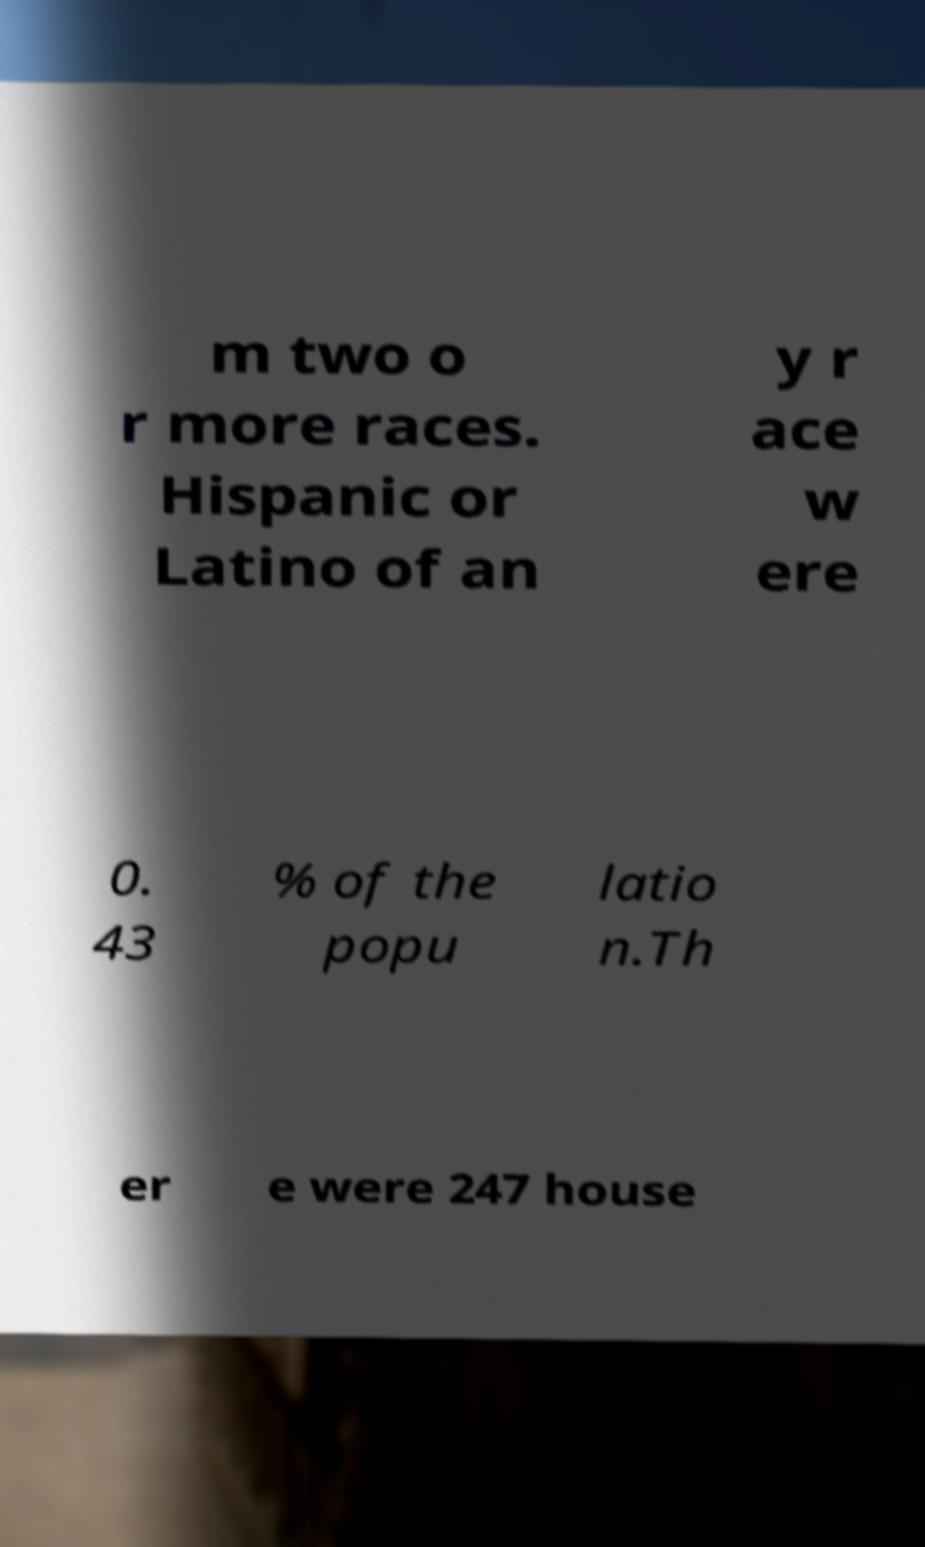Could you assist in decoding the text presented in this image and type it out clearly? m two o r more races. Hispanic or Latino of an y r ace w ere 0. 43 % of the popu latio n.Th er e were 247 house 